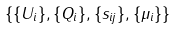<formula> <loc_0><loc_0><loc_500><loc_500>\{ \{ U _ { i } \} , \{ Q _ { i } \} , \{ s _ { i j } \} , \{ \mu _ { i } \} \}</formula> 